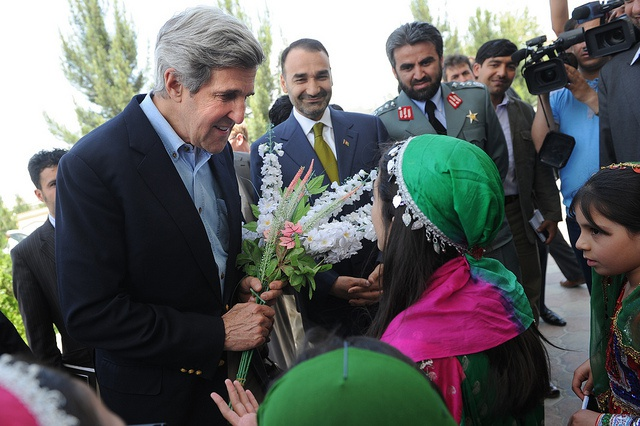Describe the objects in this image and their specific colors. I can see people in white, black, darkgray, and gray tones, people in white, black, purple, green, and darkgreen tones, people in white, black, gray, and darkblue tones, people in white, black, gray, and maroon tones, and people in white, darkgreen, green, and black tones in this image. 